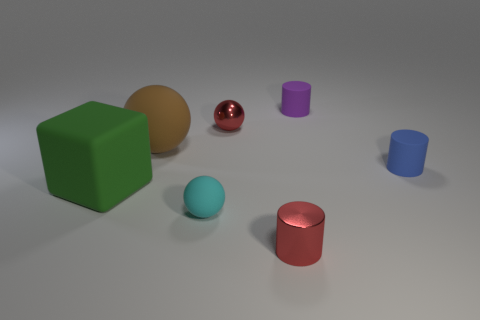There is a red thing in front of the large brown matte sphere; what number of things are right of it?
Ensure brevity in your answer.  2. Is the shiny ball the same color as the tiny shiny cylinder?
Provide a short and direct response. Yes. What number of other things are the same material as the green cube?
Keep it short and to the point. 4. What shape is the shiny object that is in front of the red metal thing that is behind the big brown sphere?
Your answer should be very brief. Cylinder. What is the size of the matte cylinder on the right side of the tiny purple cylinder?
Keep it short and to the point. Small. Do the green cube and the red ball have the same material?
Keep it short and to the point. No. The thing that is made of the same material as the tiny red cylinder is what shape?
Keep it short and to the point. Sphere. Are there any other things that have the same color as the big sphere?
Make the answer very short. No. What color is the small shiny object that is in front of the big green object?
Provide a short and direct response. Red. Does the tiny cylinder on the left side of the purple rubber object have the same color as the tiny shiny sphere?
Provide a succinct answer. Yes. 